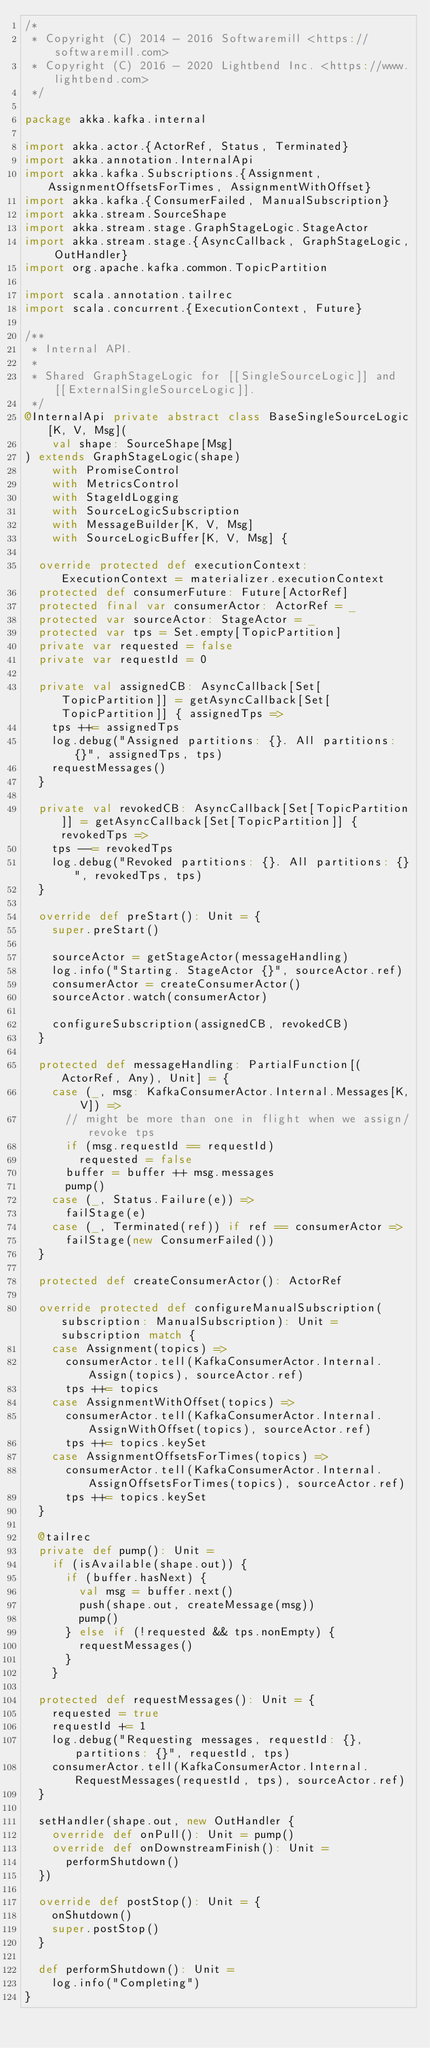<code> <loc_0><loc_0><loc_500><loc_500><_Scala_>/*
 * Copyright (C) 2014 - 2016 Softwaremill <https://softwaremill.com>
 * Copyright (C) 2016 - 2020 Lightbend Inc. <https://www.lightbend.com>
 */

package akka.kafka.internal

import akka.actor.{ActorRef, Status, Terminated}
import akka.annotation.InternalApi
import akka.kafka.Subscriptions.{Assignment, AssignmentOffsetsForTimes, AssignmentWithOffset}
import akka.kafka.{ConsumerFailed, ManualSubscription}
import akka.stream.SourceShape
import akka.stream.stage.GraphStageLogic.StageActor
import akka.stream.stage.{AsyncCallback, GraphStageLogic, OutHandler}
import org.apache.kafka.common.TopicPartition

import scala.annotation.tailrec
import scala.concurrent.{ExecutionContext, Future}

/**
 * Internal API.
 *
 * Shared GraphStageLogic for [[SingleSourceLogic]] and [[ExternalSingleSourceLogic]].
 */
@InternalApi private abstract class BaseSingleSourceLogic[K, V, Msg](
    val shape: SourceShape[Msg]
) extends GraphStageLogic(shape)
    with PromiseControl
    with MetricsControl
    with StageIdLogging
    with SourceLogicSubscription
    with MessageBuilder[K, V, Msg]
    with SourceLogicBuffer[K, V, Msg] {

  override protected def executionContext: ExecutionContext = materializer.executionContext
  protected def consumerFuture: Future[ActorRef]
  protected final var consumerActor: ActorRef = _
  protected var sourceActor: StageActor = _
  protected var tps = Set.empty[TopicPartition]
  private var requested = false
  private var requestId = 0

  private val assignedCB: AsyncCallback[Set[TopicPartition]] = getAsyncCallback[Set[TopicPartition]] { assignedTps =>
    tps ++= assignedTps
    log.debug("Assigned partitions: {}. All partitions: {}", assignedTps, tps)
    requestMessages()
  }

  private val revokedCB: AsyncCallback[Set[TopicPartition]] = getAsyncCallback[Set[TopicPartition]] { revokedTps =>
    tps --= revokedTps
    log.debug("Revoked partitions: {}. All partitions: {}", revokedTps, tps)
  }

  override def preStart(): Unit = {
    super.preStart()

    sourceActor = getStageActor(messageHandling)
    log.info("Starting. StageActor {}", sourceActor.ref)
    consumerActor = createConsumerActor()
    sourceActor.watch(consumerActor)

    configureSubscription(assignedCB, revokedCB)
  }

  protected def messageHandling: PartialFunction[(ActorRef, Any), Unit] = {
    case (_, msg: KafkaConsumerActor.Internal.Messages[K, V]) =>
      // might be more than one in flight when we assign/revoke tps
      if (msg.requestId == requestId)
        requested = false
      buffer = buffer ++ msg.messages
      pump()
    case (_, Status.Failure(e)) =>
      failStage(e)
    case (_, Terminated(ref)) if ref == consumerActor =>
      failStage(new ConsumerFailed())
  }

  protected def createConsumerActor(): ActorRef

  override protected def configureManualSubscription(subscription: ManualSubscription): Unit = subscription match {
    case Assignment(topics) =>
      consumerActor.tell(KafkaConsumerActor.Internal.Assign(topics), sourceActor.ref)
      tps ++= topics
    case AssignmentWithOffset(topics) =>
      consumerActor.tell(KafkaConsumerActor.Internal.AssignWithOffset(topics), sourceActor.ref)
      tps ++= topics.keySet
    case AssignmentOffsetsForTimes(topics) =>
      consumerActor.tell(KafkaConsumerActor.Internal.AssignOffsetsForTimes(topics), sourceActor.ref)
      tps ++= topics.keySet
  }

  @tailrec
  private def pump(): Unit =
    if (isAvailable(shape.out)) {
      if (buffer.hasNext) {
        val msg = buffer.next()
        push(shape.out, createMessage(msg))
        pump()
      } else if (!requested && tps.nonEmpty) {
        requestMessages()
      }
    }

  protected def requestMessages(): Unit = {
    requested = true
    requestId += 1
    log.debug("Requesting messages, requestId: {}, partitions: {}", requestId, tps)
    consumerActor.tell(KafkaConsumerActor.Internal.RequestMessages(requestId, tps), sourceActor.ref)
  }

  setHandler(shape.out, new OutHandler {
    override def onPull(): Unit = pump()
    override def onDownstreamFinish(): Unit =
      performShutdown()
  })

  override def postStop(): Unit = {
    onShutdown()
    super.postStop()
  }

  def performShutdown(): Unit =
    log.info("Completing")
}
</code> 